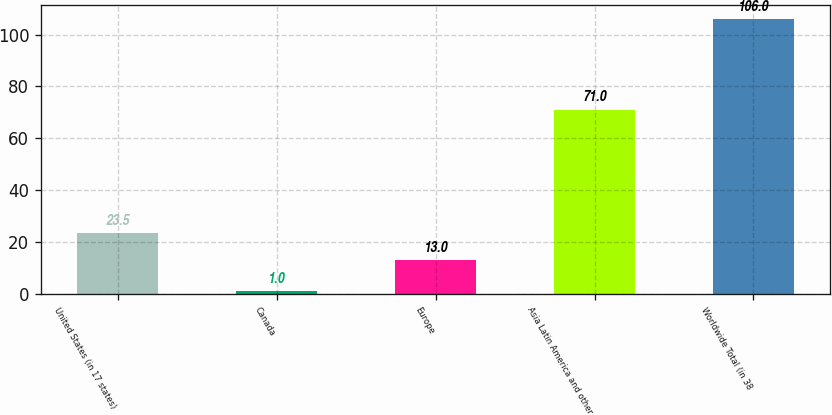<chart> <loc_0><loc_0><loc_500><loc_500><bar_chart><fcel>United States (in 17 states)<fcel>Canada<fcel>Europe<fcel>Asia Latin America and other<fcel>Worldwide Total (in 38<nl><fcel>23.5<fcel>1<fcel>13<fcel>71<fcel>106<nl></chart> 